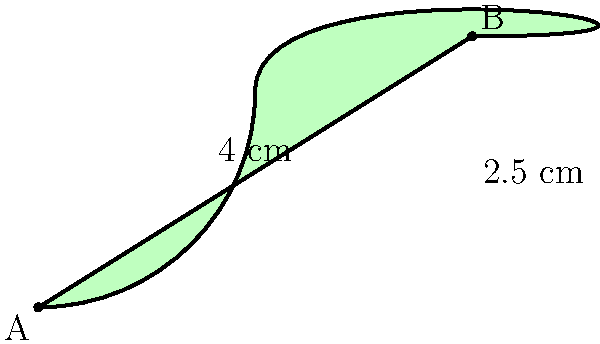In your latest comic strip, you've drawn a witty speech bubble with curved edges. The bubble's shape resembles the path from point A to B, with a width of 4 cm and a height of 2.5 cm at its tallest point. If you approximate the area using the formula $A = \frac{2}{3} \times width \times height$, what is the estimated area of your speech bubble in square centimeters? Round your answer to one decimal place. To estimate the area of the speech bubble, we'll use the given formula:

$A = \frac{2}{3} \times width \times height$

Let's plug in the values:
- Width = 4 cm
- Height = 2.5 cm

$A = \frac{2}{3} \times 4 \times 2.5$

Now, let's calculate step by step:

1) First, multiply 4 and 2.5:
   $A = \frac{2}{3} \times 10$

2) Now, multiply by $\frac{2}{3}$:
   $A = \frac{20}{3}$

3) Divide 20 by 3:
   $A \approx 6.666667$

4) Rounding to one decimal place:
   $A \approx 6.7$ cm²

This approximation method gives us a reasonable estimate of the speech bubble's area, accounting for its curved shape.
Answer: 6.7 cm² 